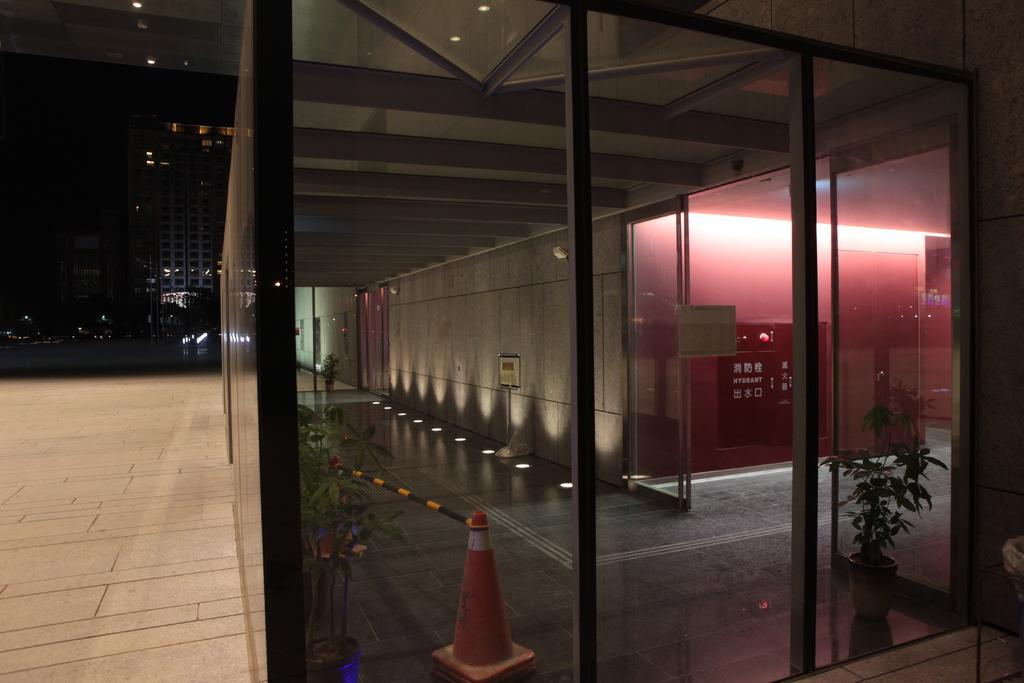Could you give a brief overview of what you see in this image? Here in this picture we can see front part of a building, which is covered with glass over there and we can see plants here and there and we can see lights present on the floor and in the far we can see buildings present all over there and we can see light posts here and there. 